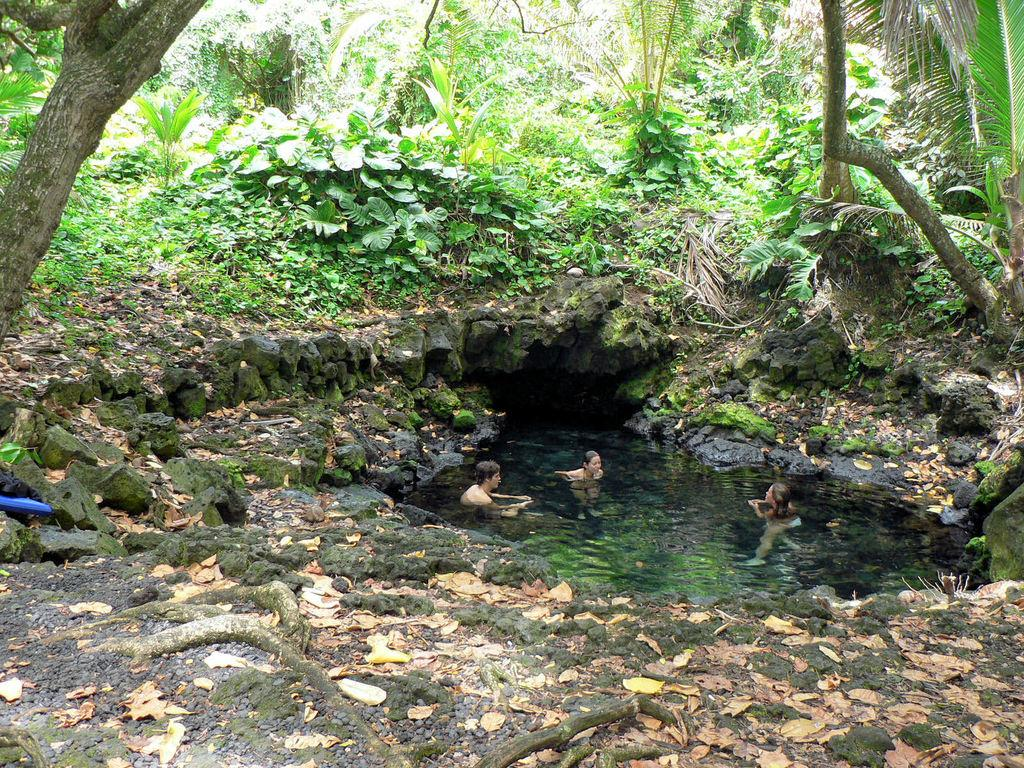What are the people in the image doing? The people in the image are in the water. What natural elements can be seen in the image? Rocks, plants, and trees are visible in the image. What type of rhythm can be heard coming from the shoe in the image? There is no shoe present in the image, so it is not possible to determine any rhythm associated with it. 